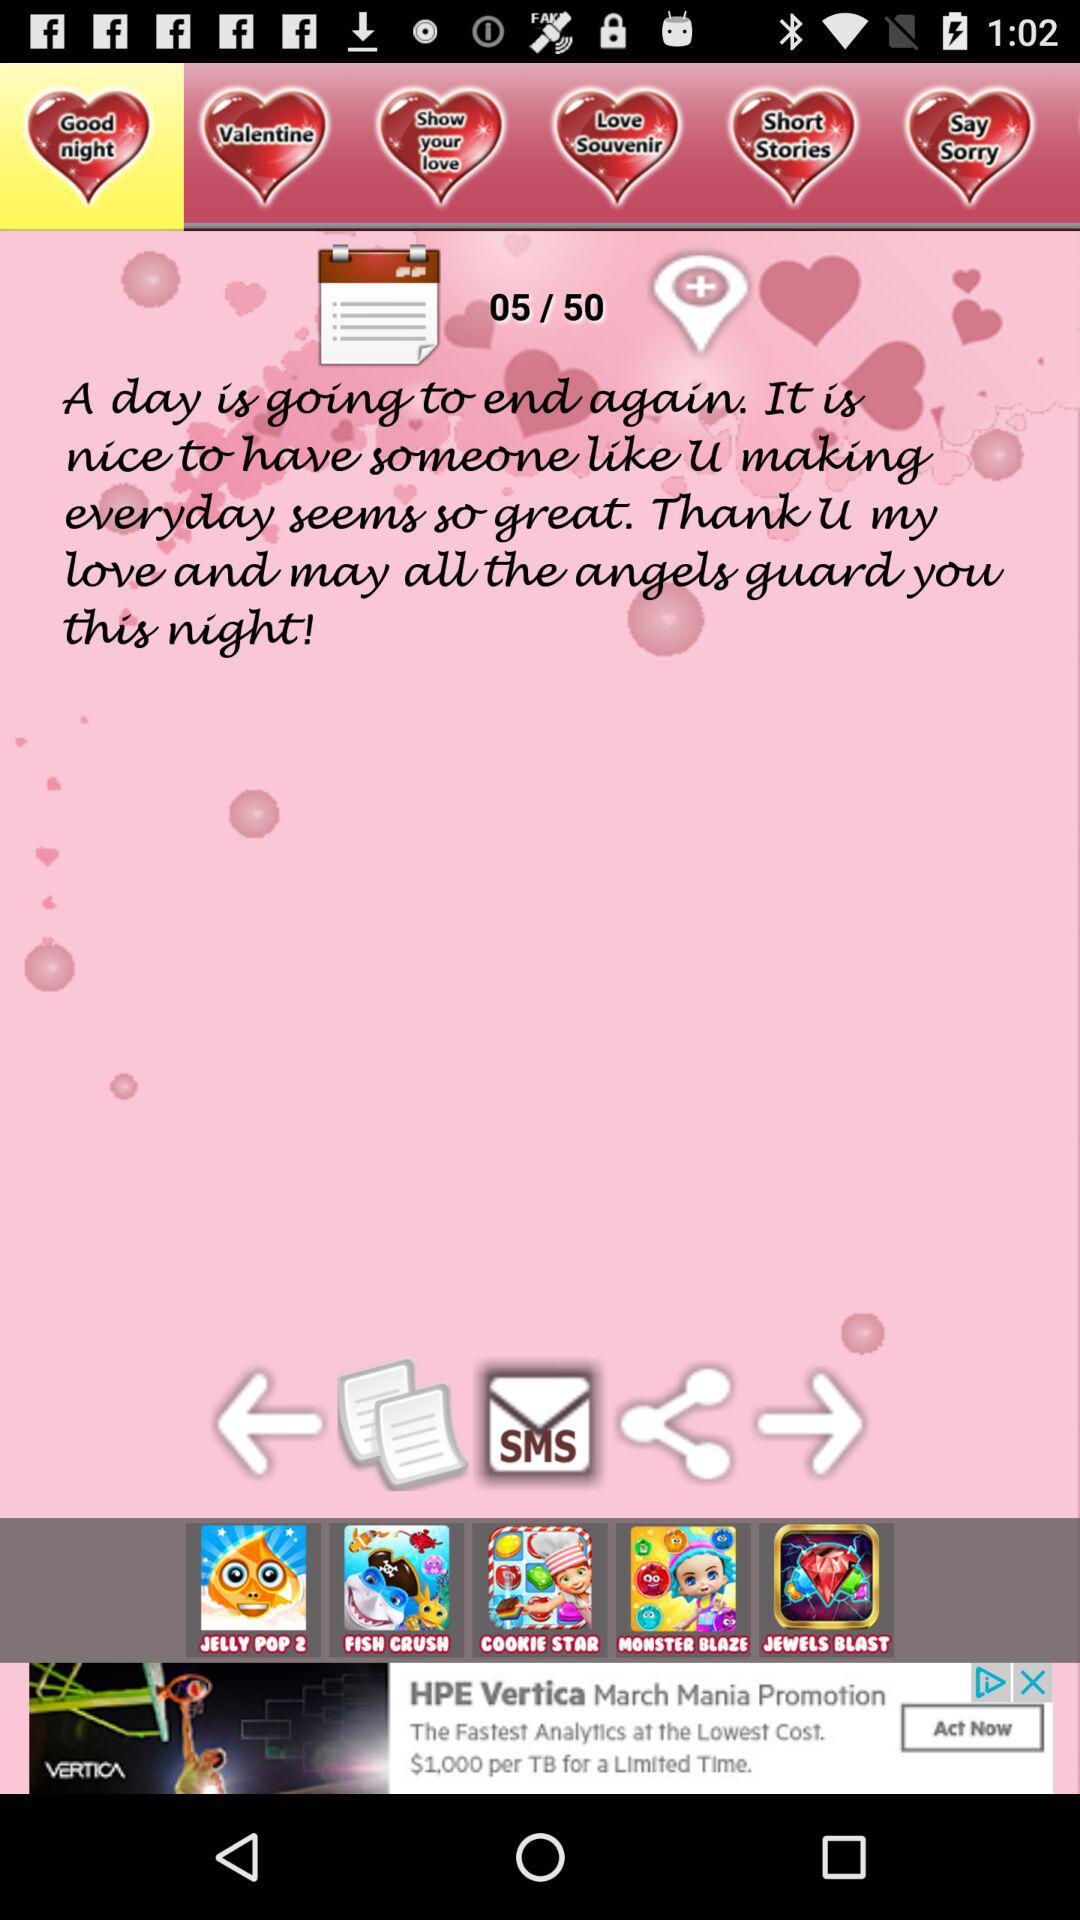On which page is the person? The person is on page number 5. 